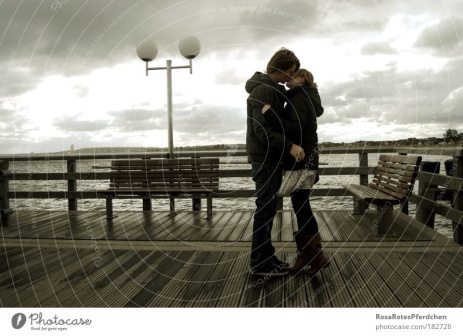What can you say about the mood and setting here? The overcast sky and the empty pier create a mood of serenity but also a hint of melancholy. The muted colors of the setting suggest peaceful reflection and introspection, while the couple's embrace provides a stark contrast, bringing warmth and intimacy to the scene. Do you think this is a place they visit often? It seems likely that this place holds special significance for them, possibly a location they visit often to reconnect and reflect. The familiarity might bring them comfort and a sense of belonging, reinforcing their bond each time they return. Describe a possible backstory for the pier itself. This pier could have a rich history, once bustling with activity, filled with the sounds of fishermen's nets and the laughter of children playing nearby. Over time, the pier might have seen fewer visitors, becoming a quiet place of solitude and reflection. It stands as a silent witness to countless stories and memories, waiting to embrace new moments of significance like the one shared by this couple. If this scene were part of a movie, what would happen next? If this scene were part of a movie, the next moment might involve the couple making a pivotal decision, perhaps choosing to embark on a new adventure or revisiting a dream they've long set aside. The camera might pan out to reveal more about their surroundings, hinting at the broader context of their story. Maybe the sky starts to clear, symbolizing new hope and clarity as they walk hand-in-hand into the next chapter of their lives. 